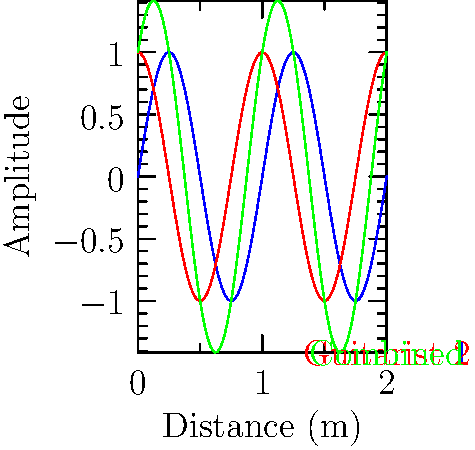Two guitarists on stage are playing the same note, but their sound waves arrive at a point in the audience with a phase difference of $\frac{\pi}{2}$ radians. Given the graph showing the individual and combined sound waves, what is the maximum amplitude of the resulting interference pattern relative to the amplitude of each individual wave? To solve this problem, let's follow these steps:

1. Identify the waves: 
   - Blue wave: Guitarist 1
   - Red wave: Guitarist 2
   - Green wave: Combined interference pattern

2. Observe the phase difference:
   The red wave is shifted by $\frac{\pi}{2}$ radians (quarter wavelength) compared to the blue wave.

3. Understand constructive interference:
   The maximum amplitude of the interference pattern occurs when both waves contribute positively.

4. Calculate the maximum amplitude:
   For two waves with equal amplitude $A$ and a phase difference $\phi$, the maximum amplitude of the resulting wave is given by:

   $$A_{max} = A\sqrt{2(1 + \cos\phi)}$$

   In this case, $\phi = \frac{\pi}{2}$, so:

   $$A_{max} = A\sqrt{2(1 + \cos\frac{\pi}{2})} = A\sqrt{2(1 + 0)} = A\sqrt{2}$$

5. Express the result relative to the original amplitude:
   The maximum amplitude of the interference pattern is $\sqrt{2}$ times the amplitude of each individual wave.

This result can be verified visually from the graph, where the green wave's maximum amplitude is indeed $\sqrt{2}$ times that of the blue or red waves.
Answer: $\sqrt{2}$ times the original amplitude 